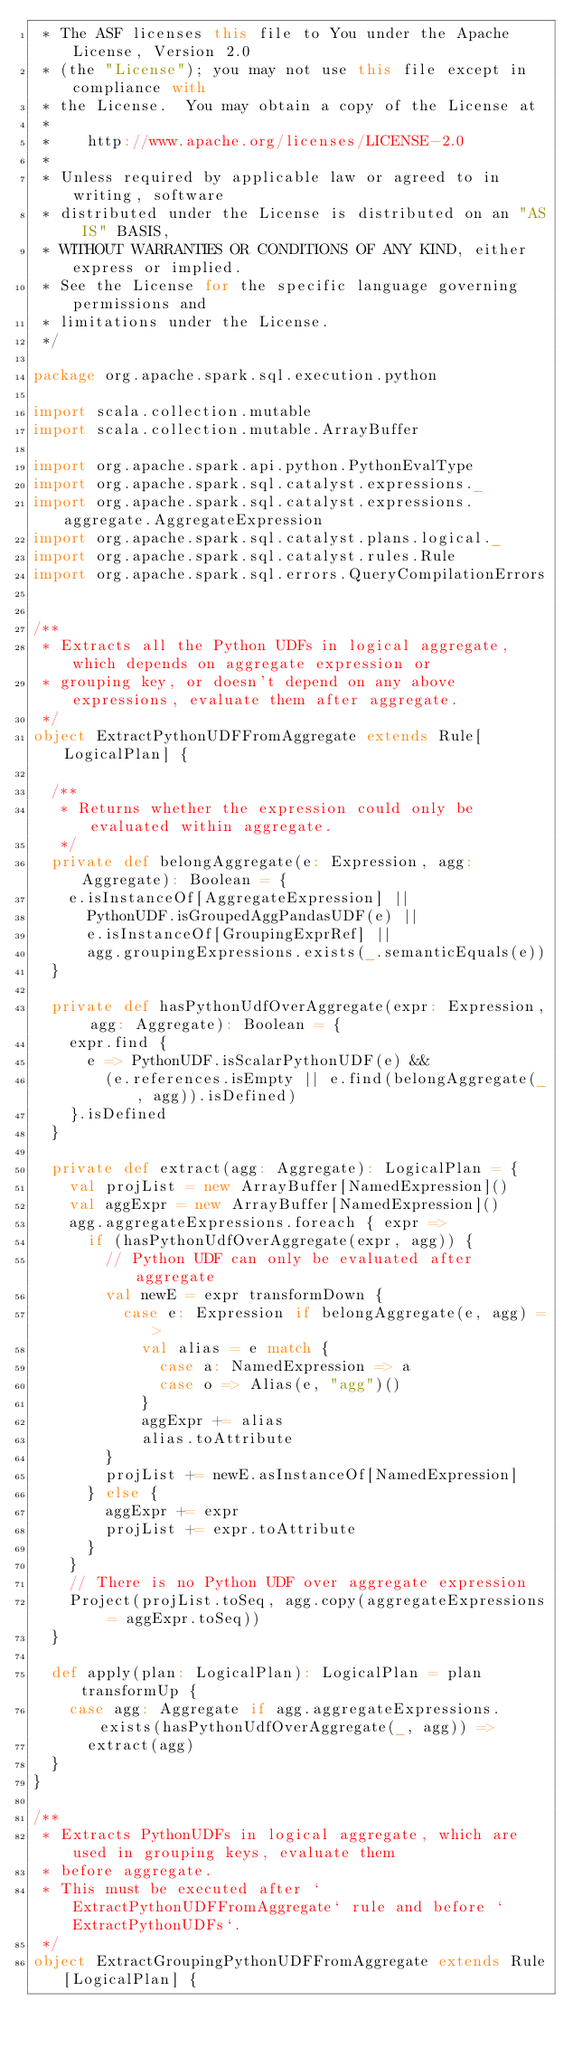Convert code to text. <code><loc_0><loc_0><loc_500><loc_500><_Scala_> * The ASF licenses this file to You under the Apache License, Version 2.0
 * (the "License"); you may not use this file except in compliance with
 * the License.  You may obtain a copy of the License at
 *
 *    http://www.apache.org/licenses/LICENSE-2.0
 *
 * Unless required by applicable law or agreed to in writing, software
 * distributed under the License is distributed on an "AS IS" BASIS,
 * WITHOUT WARRANTIES OR CONDITIONS OF ANY KIND, either express or implied.
 * See the License for the specific language governing permissions and
 * limitations under the License.
 */

package org.apache.spark.sql.execution.python

import scala.collection.mutable
import scala.collection.mutable.ArrayBuffer

import org.apache.spark.api.python.PythonEvalType
import org.apache.spark.sql.catalyst.expressions._
import org.apache.spark.sql.catalyst.expressions.aggregate.AggregateExpression
import org.apache.spark.sql.catalyst.plans.logical._
import org.apache.spark.sql.catalyst.rules.Rule
import org.apache.spark.sql.errors.QueryCompilationErrors


/**
 * Extracts all the Python UDFs in logical aggregate, which depends on aggregate expression or
 * grouping key, or doesn't depend on any above expressions, evaluate them after aggregate.
 */
object ExtractPythonUDFFromAggregate extends Rule[LogicalPlan] {

  /**
   * Returns whether the expression could only be evaluated within aggregate.
   */
  private def belongAggregate(e: Expression, agg: Aggregate): Boolean = {
    e.isInstanceOf[AggregateExpression] ||
      PythonUDF.isGroupedAggPandasUDF(e) ||
      e.isInstanceOf[GroupingExprRef] ||
      agg.groupingExpressions.exists(_.semanticEquals(e))
  }

  private def hasPythonUdfOverAggregate(expr: Expression, agg: Aggregate): Boolean = {
    expr.find {
      e => PythonUDF.isScalarPythonUDF(e) &&
        (e.references.isEmpty || e.find(belongAggregate(_, agg)).isDefined)
    }.isDefined
  }

  private def extract(agg: Aggregate): LogicalPlan = {
    val projList = new ArrayBuffer[NamedExpression]()
    val aggExpr = new ArrayBuffer[NamedExpression]()
    agg.aggregateExpressions.foreach { expr =>
      if (hasPythonUdfOverAggregate(expr, agg)) {
        // Python UDF can only be evaluated after aggregate
        val newE = expr transformDown {
          case e: Expression if belongAggregate(e, agg) =>
            val alias = e match {
              case a: NamedExpression => a
              case o => Alias(e, "agg")()
            }
            aggExpr += alias
            alias.toAttribute
        }
        projList += newE.asInstanceOf[NamedExpression]
      } else {
        aggExpr += expr
        projList += expr.toAttribute
      }
    }
    // There is no Python UDF over aggregate expression
    Project(projList.toSeq, agg.copy(aggregateExpressions = aggExpr.toSeq))
  }

  def apply(plan: LogicalPlan): LogicalPlan = plan transformUp {
    case agg: Aggregate if agg.aggregateExpressions.exists(hasPythonUdfOverAggregate(_, agg)) =>
      extract(agg)
  }
}

/**
 * Extracts PythonUDFs in logical aggregate, which are used in grouping keys, evaluate them
 * before aggregate.
 * This must be executed after `ExtractPythonUDFFromAggregate` rule and before `ExtractPythonUDFs`.
 */
object ExtractGroupingPythonUDFFromAggregate extends Rule[LogicalPlan] {</code> 